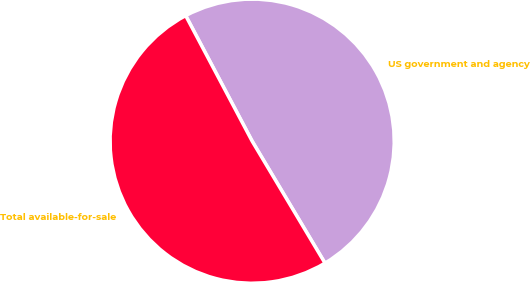<chart> <loc_0><loc_0><loc_500><loc_500><pie_chart><fcel>US government and agency<fcel>Total available-for-sale<nl><fcel>49.18%<fcel>50.82%<nl></chart> 